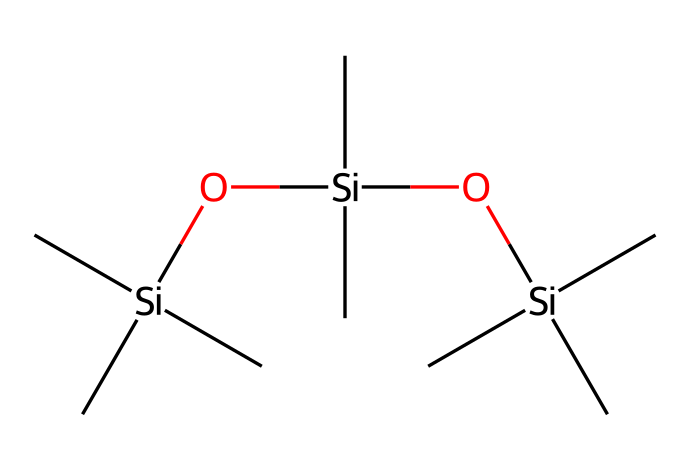What is the total number of silicon atoms in this compound? By examining the provided SMILES representation, we can count the number of silicon atoms (Si). Each occurrence of 'Si' indicates a silicon atom, and in this structure, there are three instances of 'Si'.
Answer: three How many oxygen atoms are present in the structure? In the SMILES notation, 'O' represents oxygen atoms. By counting the occurrences of 'O' in the given structure, we find there are two oxygen atoms present.
Answer: two What type of chemical bond is primarily found in organosilicon compounds? Organosilicon compounds predominantly feature covalent bonds. The silicon atoms in this structure form covalent bonds with carbon and oxygen atoms.
Answer: covalent Based on the structure, how many carbon atoms are in the compound? Analyzing the SMILES representation, we count the number of carbon atoms (C). Each 'C' denotes a carbon atom, and in this case, there are nine carbon atoms present in the structure.
Answer: nine What functional group is indicated by the presence of oxygen in this molecule? The presence of oxygen atoms here suggests the functional group is silanol (Si-OH) or related ethers in the context of organosilicon compounds. This indicates the molecule's potential for compatibility with various solvents and skin.
Answer: silanol What is the main characteristic of silicon in cosmetic applications? The primary characteristic of silicon in cosmetics, particularly in makeup removers, is its ability to provide a smooth, silky texture which helps in the effective removal of makeup.
Answer: smooth texture 